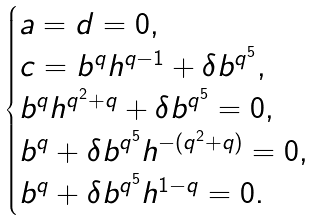Convert formula to latex. <formula><loc_0><loc_0><loc_500><loc_500>\begin{cases} a = d = 0 , \\ c = b ^ { q } h ^ { q - 1 } + \delta b ^ { q ^ { 5 } } , \\ b ^ { q } h ^ { q ^ { 2 } + q } + \delta b ^ { q ^ { 5 } } = 0 , \\ b ^ { q } + \delta b ^ { q ^ { 5 } } h ^ { - ( q ^ { 2 } + q ) } = 0 , \\ b ^ { q } + \delta b ^ { q ^ { 5 } } h ^ { 1 - q } = 0 . \\ \end{cases}</formula> 